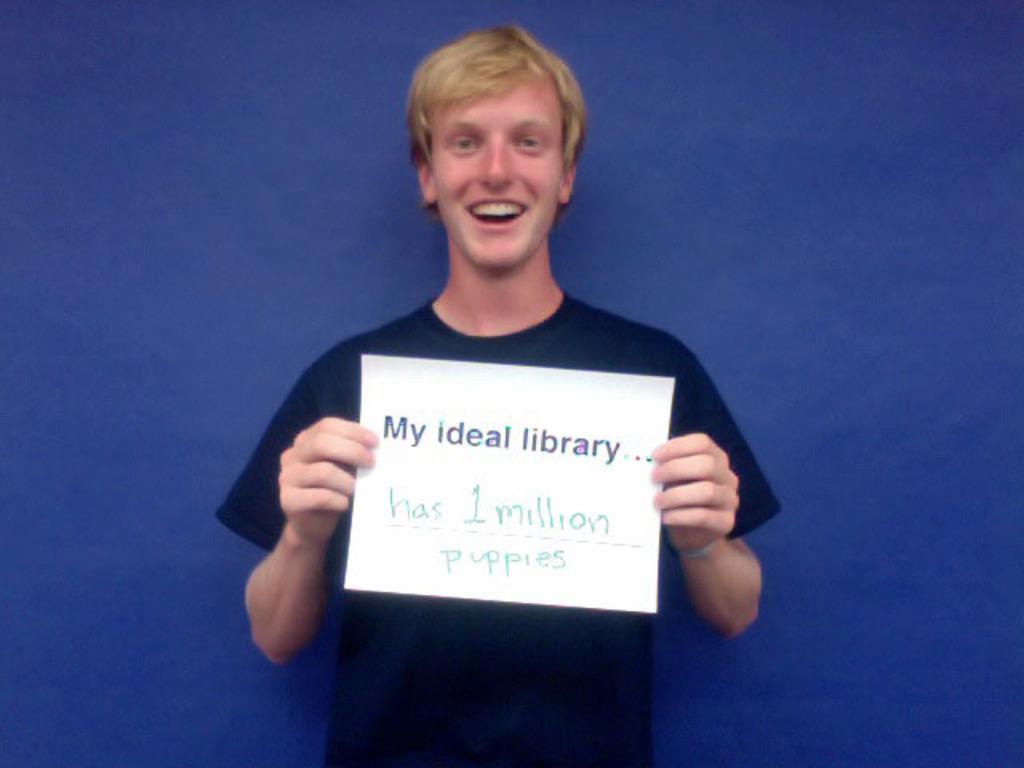Could you give a brief overview of what you see in this image? In the image we can see a boy is standing, wearing clothes and he is wearing clothes and he is smiling and he is holding a paper in his hands. On the paper there is a text and the background is blue. 